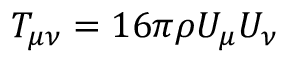Convert formula to latex. <formula><loc_0><loc_0><loc_500><loc_500>T _ { \mu \nu } = 1 6 \pi \rho U _ { \mu } U _ { \nu }</formula> 